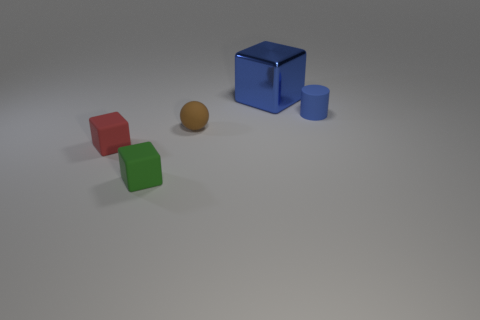What is the material of the red object that is the same size as the cylinder?
Offer a terse response. Rubber. What number of tiny objects are shiny objects or brown rubber cylinders?
Make the answer very short. 0. What number of things are either things that are left of the blue shiny cube or rubber objects to the left of the blue cylinder?
Provide a succinct answer. 3. Is the number of gray metallic spheres less than the number of matte balls?
Make the answer very short. Yes. What shape is the brown rubber object that is the same size as the matte cylinder?
Offer a terse response. Sphere. How many other things are there of the same color as the big metallic cube?
Give a very brief answer. 1. What number of large purple blocks are there?
Give a very brief answer. 0. What number of rubber things are in front of the blue matte cylinder and right of the blue metallic block?
Give a very brief answer. 0. What material is the large thing?
Provide a succinct answer. Metal. Are there any green matte cubes?
Offer a very short reply. Yes. 